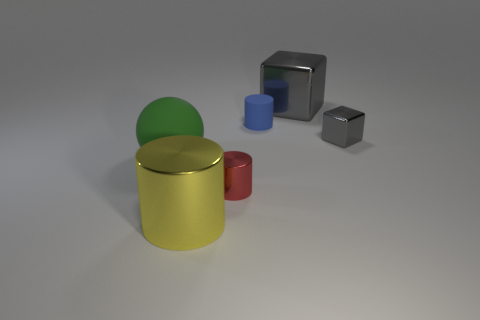Subtract 1 cylinders. How many cylinders are left? 2 Add 3 gray metallic cubes. How many objects exist? 9 Subtract all cubes. How many objects are left? 4 Subtract 0 cyan spheres. How many objects are left? 6 Subtract all tiny purple shiny cubes. Subtract all tiny red shiny objects. How many objects are left? 5 Add 4 green matte things. How many green matte things are left? 5 Add 6 gray shiny blocks. How many gray shiny blocks exist? 8 